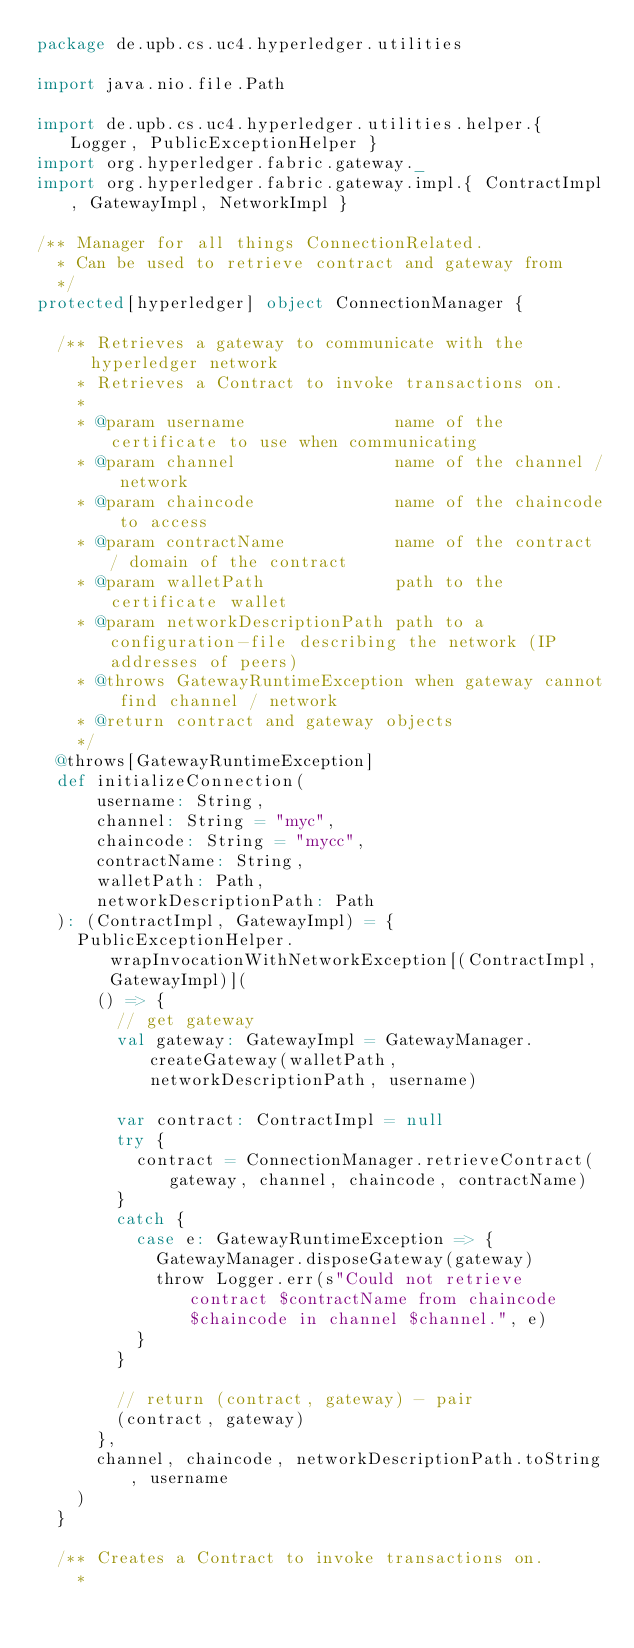<code> <loc_0><loc_0><loc_500><loc_500><_Scala_>package de.upb.cs.uc4.hyperledger.utilities

import java.nio.file.Path

import de.upb.cs.uc4.hyperledger.utilities.helper.{ Logger, PublicExceptionHelper }
import org.hyperledger.fabric.gateway._
import org.hyperledger.fabric.gateway.impl.{ ContractImpl, GatewayImpl, NetworkImpl }

/** Manager for all things ConnectionRelated.
  * Can be used to retrieve contract and gateway from
  */
protected[hyperledger] object ConnectionManager {

  /** Retrieves a gateway to communicate with the hyperledger network
    * Retrieves a Contract to invoke transactions on.
    *
    * @param username               name of the certificate to use when communicating
    * @param channel                name of the channel / network
    * @param chaincode              name of the chaincode to access
    * @param contractName           name of the contract / domain of the contract
    * @param walletPath             path to the certificate wallet
    * @param networkDescriptionPath path to a configuration-file describing the network (IP addresses of peers)
    * @throws GatewayRuntimeException when gateway cannot find channel / network
    * @return contract and gateway objects
    */
  @throws[GatewayRuntimeException]
  def initializeConnection(
      username: String,
      channel: String = "myc",
      chaincode: String = "mycc",
      contractName: String,
      walletPath: Path,
      networkDescriptionPath: Path
  ): (ContractImpl, GatewayImpl) = {
    PublicExceptionHelper.wrapInvocationWithNetworkException[(ContractImpl, GatewayImpl)](
      () => {
        // get gateway
        val gateway: GatewayImpl = GatewayManager.createGateway(walletPath, networkDescriptionPath, username)

        var contract: ContractImpl = null
        try {
          contract = ConnectionManager.retrieveContract(gateway, channel, chaincode, contractName)
        }
        catch {
          case e: GatewayRuntimeException => {
            GatewayManager.disposeGateway(gateway)
            throw Logger.err(s"Could not retrieve contract $contractName from chaincode $chaincode in channel $channel.", e)
          }
        }

        // return (contract, gateway) - pair
        (contract, gateway)
      },
      channel, chaincode, networkDescriptionPath.toString, username
    )
  }

  /** Creates a Contract to invoke transactions on.
    *</code> 